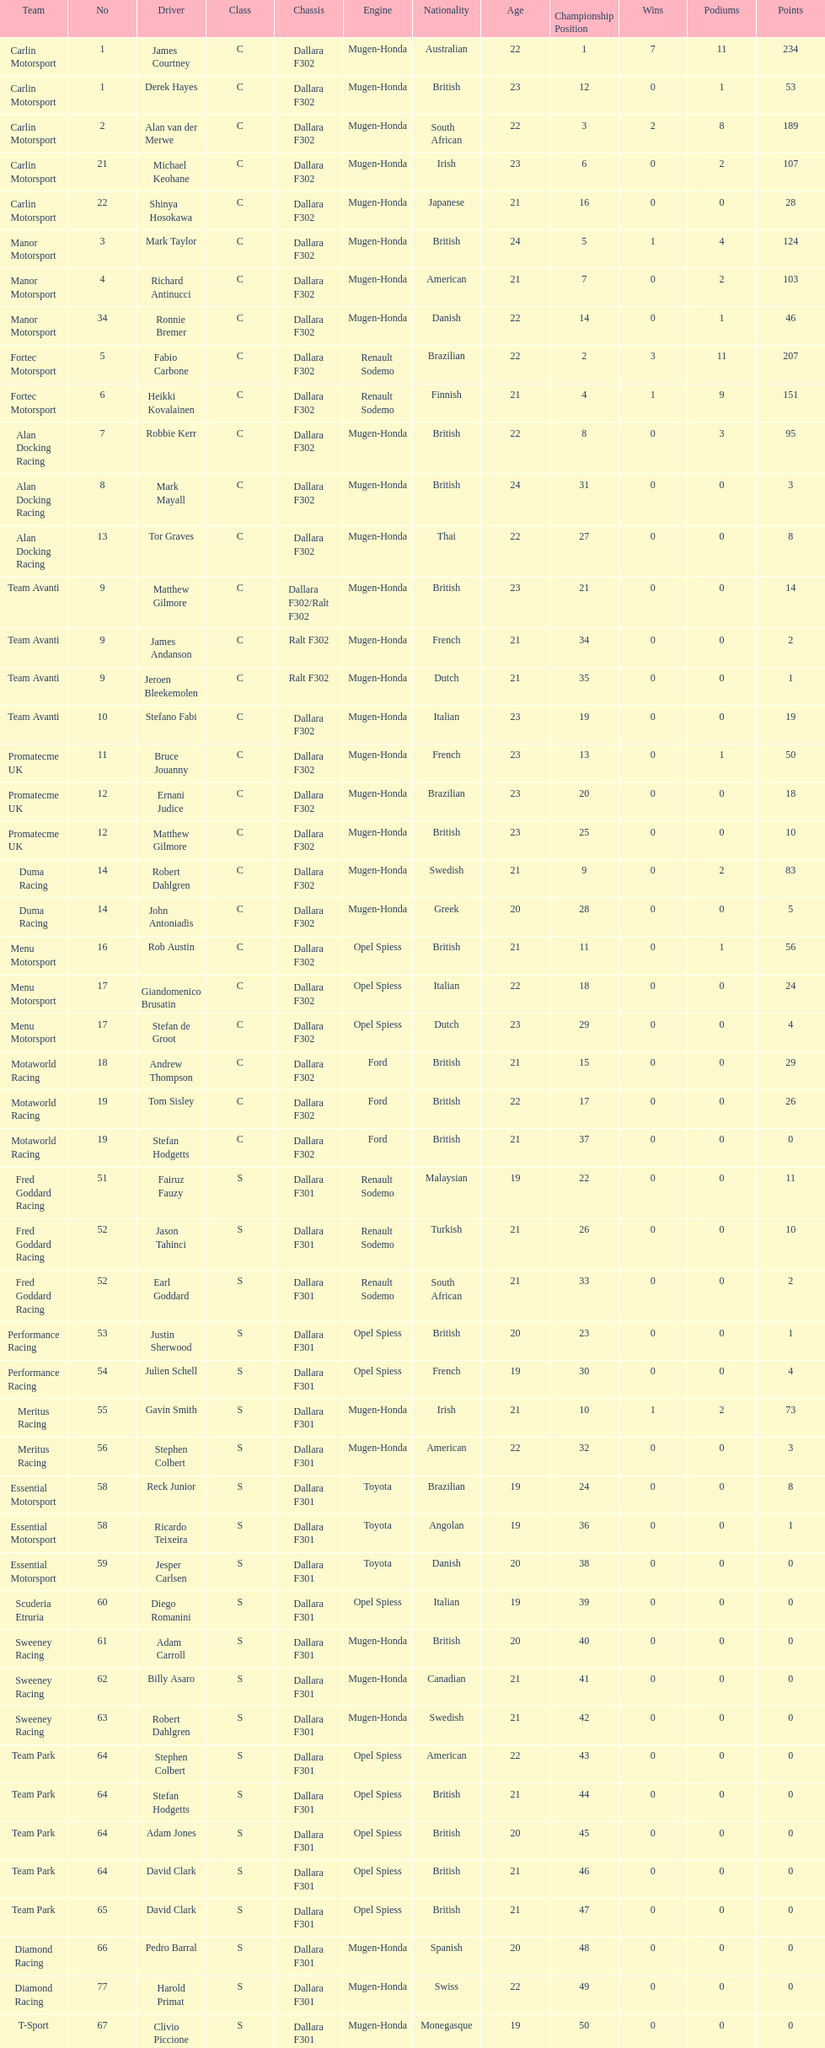How many class s (scholarship) teams are on the chart? 19. 